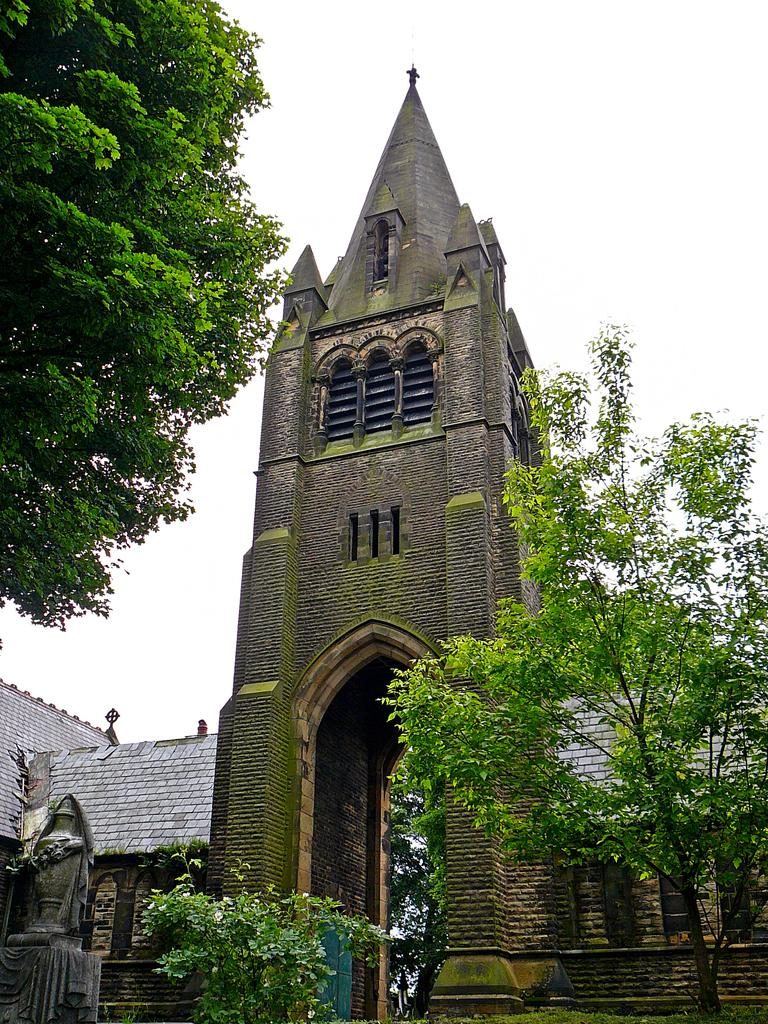What is the main subject of the picture? The main subject of the picture is an architecture. What can be seen around the architecture? There are trees around the architecture. What other object is visible on the left side of the picture? There is a sculpture on the left side of the picture. What is the profit margin of the school depicted in the image? There is no school present in the image, and therefore no profit margin can be determined. 